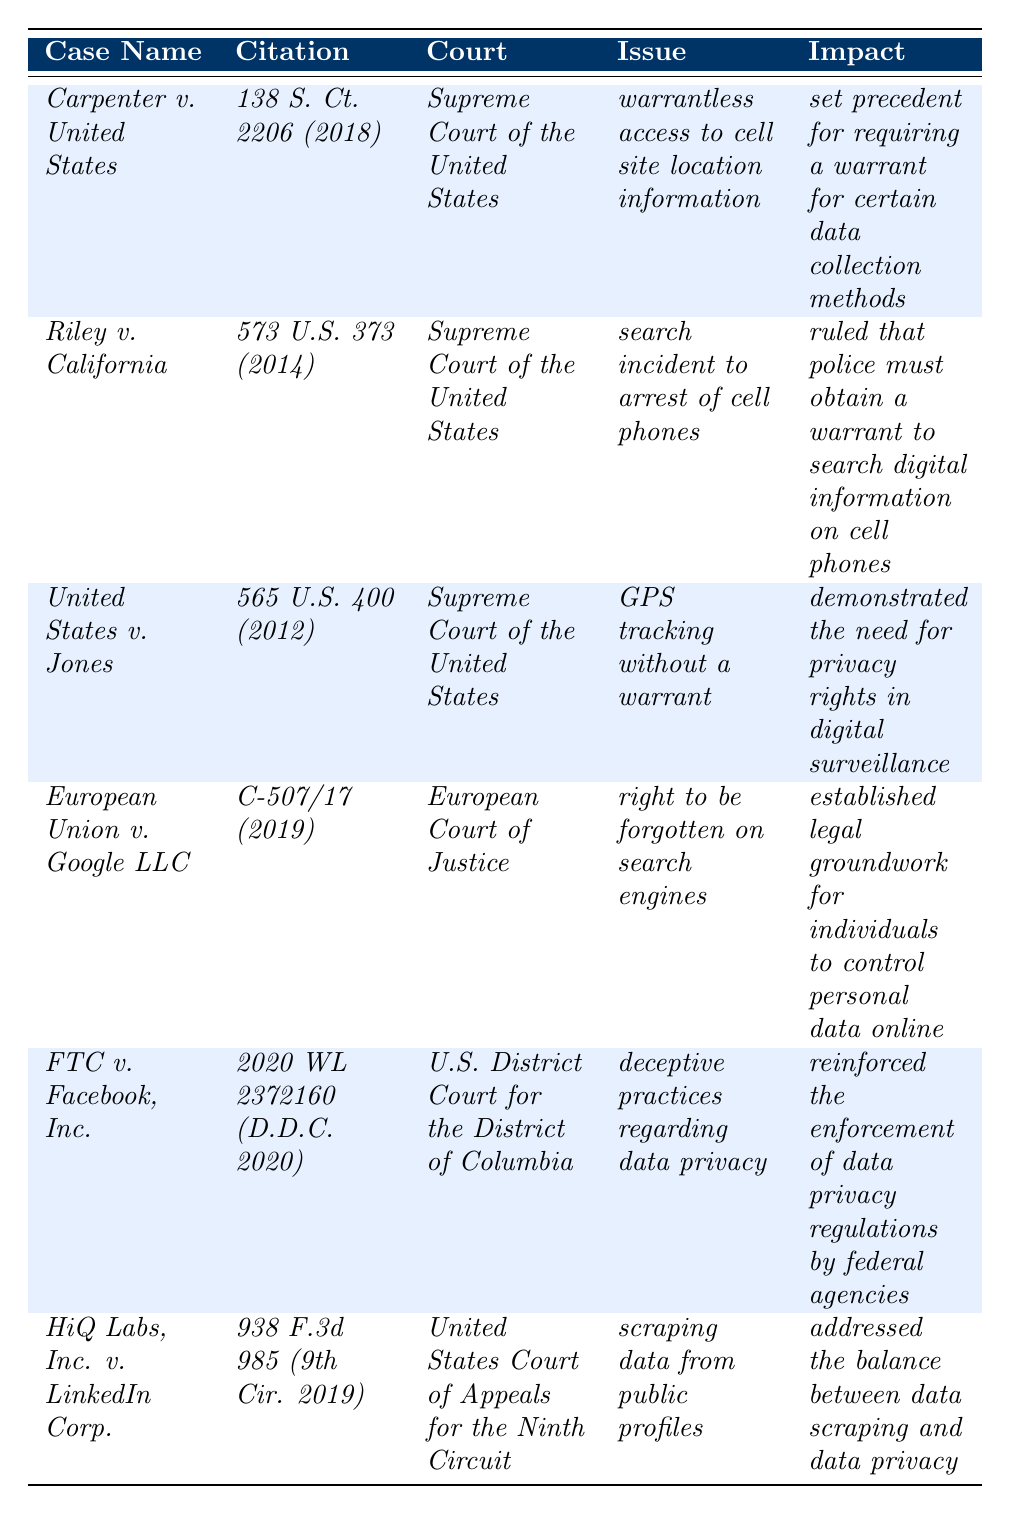What is the citation for _Carpenter v. United States_? The citation is found in the second column of the row corresponding to _Carpenter v. United States_, which states "138 S. Ct. 2206 (2018)".
Answer: 138 S. Ct. 2206 (2018) Which court decided _Riley v. California_? The court that decided this case is mentioned in the third column next to the case name _Riley v. California_, which states "Supreme Court of the United States".
Answer: Supreme Court of the United States How many cases listed involve the Supreme Court of the United States? By reviewing the table, _Carpenter v. United States_, _Riley v. California_, and _United States v. Jones_ are all listed under the Supreme Court of the United States, making it three cases.
Answer: 3 Is _HiQ Labs, Inc. v. LinkedIn Corp._ related to the issue of data scraping? The issue described in the fourth column for _HiQ Labs, Inc. v. LinkedIn Corp._ specifically mentions "scraping data from public profiles," confirming its relation to data scraping.
Answer: Yes What is the primary impact stated for _European Union v. Google LLC_? The impact is detailed in the last column for the respective case, stating it "established legal groundwork for individuals to control personal data online."
Answer: Established legal groundwork for individuals to control personal data online Compare the issues in _FTC v. Facebook, Inc._ and _Riley v. California_. What is the difference? _FTC v. Facebook, Inc._ deals with "deceptive practices regarding data privacy," while _Riley v. California_ involves "search incident to arrest of cell phones." Thus, the issues are different in focus; one pertains to business practices and the other to law enforcement procedures.
Answer: The issues are different; one concerns business practices, the other law enforcement What is the total number of different courts represented in the table? The courts involved are Supreme Court of the United States, European Court of Justice, U.S. District Court for the District of Columbia, and United States Court of Appeals for the Ninth Circuit, totaling four different courts.
Answer: 4 Determine if there is a case that involves GPS tracking. If so, which one? Looking at the issue column, _United States v. Jones_ explicitly mentions "GPS tracking without a warrant," thus confirming its involvement in GPS tracking.
Answer: Yes; _United States v. Jones_ Identify the case that set a precedent for requiring a warrant for data collection methods. _Carpenter v. United States_ is noted in the last column for having the impact of setting a precedent for requiring a warrant for certain data collection methods.
Answer: _Carpenter v. United States_ 